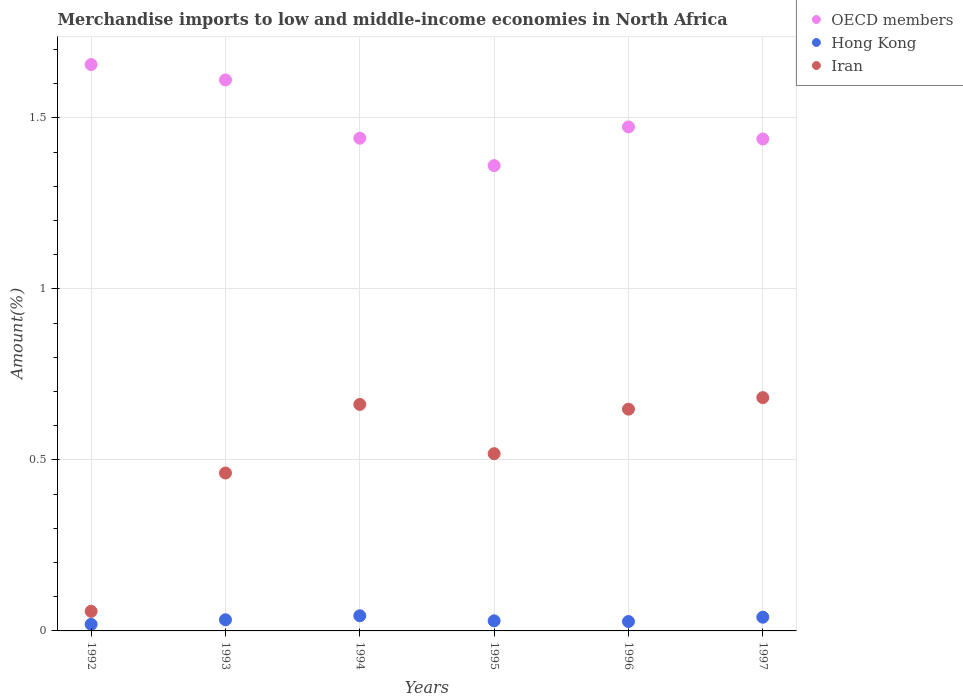What is the percentage of amount earned from merchandise imports in OECD members in 1996?
Provide a succinct answer. 1.47. Across all years, what is the maximum percentage of amount earned from merchandise imports in Hong Kong?
Keep it short and to the point. 0.04. Across all years, what is the minimum percentage of amount earned from merchandise imports in Iran?
Your response must be concise. 0.06. What is the total percentage of amount earned from merchandise imports in OECD members in the graph?
Make the answer very short. 8.98. What is the difference between the percentage of amount earned from merchandise imports in Hong Kong in 1993 and that in 1994?
Provide a short and direct response. -0.01. What is the difference between the percentage of amount earned from merchandise imports in OECD members in 1995 and the percentage of amount earned from merchandise imports in Hong Kong in 1996?
Your answer should be compact. 1.33. What is the average percentage of amount earned from merchandise imports in Iran per year?
Make the answer very short. 0.5. In the year 1993, what is the difference between the percentage of amount earned from merchandise imports in OECD members and percentage of amount earned from merchandise imports in Iran?
Ensure brevity in your answer.  1.15. What is the ratio of the percentage of amount earned from merchandise imports in Iran in 1994 to that in 1997?
Keep it short and to the point. 0.97. Is the difference between the percentage of amount earned from merchandise imports in OECD members in 1992 and 1995 greater than the difference between the percentage of amount earned from merchandise imports in Iran in 1992 and 1995?
Offer a terse response. Yes. What is the difference between the highest and the second highest percentage of amount earned from merchandise imports in Iran?
Offer a very short reply. 0.02. What is the difference between the highest and the lowest percentage of amount earned from merchandise imports in OECD members?
Provide a short and direct response. 0.3. Is the sum of the percentage of amount earned from merchandise imports in OECD members in 1993 and 1997 greater than the maximum percentage of amount earned from merchandise imports in Iran across all years?
Keep it short and to the point. Yes. Does the percentage of amount earned from merchandise imports in Iran monotonically increase over the years?
Make the answer very short. No. Is the percentage of amount earned from merchandise imports in Hong Kong strictly less than the percentage of amount earned from merchandise imports in Iran over the years?
Make the answer very short. Yes. How many years are there in the graph?
Keep it short and to the point. 6. What is the difference between two consecutive major ticks on the Y-axis?
Your answer should be very brief. 0.5. Where does the legend appear in the graph?
Give a very brief answer. Top right. How many legend labels are there?
Your answer should be very brief. 3. How are the legend labels stacked?
Provide a short and direct response. Vertical. What is the title of the graph?
Your answer should be very brief. Merchandise imports to low and middle-income economies in North Africa. Does "Gabon" appear as one of the legend labels in the graph?
Offer a very short reply. No. What is the label or title of the X-axis?
Offer a very short reply. Years. What is the label or title of the Y-axis?
Your response must be concise. Amount(%). What is the Amount(%) in OECD members in 1992?
Make the answer very short. 1.66. What is the Amount(%) in Hong Kong in 1992?
Give a very brief answer. 0.02. What is the Amount(%) of Iran in 1992?
Your answer should be compact. 0.06. What is the Amount(%) of OECD members in 1993?
Provide a short and direct response. 1.61. What is the Amount(%) of Hong Kong in 1993?
Your response must be concise. 0.03. What is the Amount(%) in Iran in 1993?
Make the answer very short. 0.46. What is the Amount(%) in OECD members in 1994?
Your answer should be compact. 1.44. What is the Amount(%) in Hong Kong in 1994?
Provide a succinct answer. 0.04. What is the Amount(%) in Iran in 1994?
Make the answer very short. 0.66. What is the Amount(%) in OECD members in 1995?
Your answer should be compact. 1.36. What is the Amount(%) in Hong Kong in 1995?
Keep it short and to the point. 0.03. What is the Amount(%) in Iran in 1995?
Provide a succinct answer. 0.52. What is the Amount(%) of OECD members in 1996?
Provide a succinct answer. 1.47. What is the Amount(%) in Hong Kong in 1996?
Your answer should be compact. 0.03. What is the Amount(%) of Iran in 1996?
Offer a very short reply. 0.65. What is the Amount(%) of OECD members in 1997?
Provide a succinct answer. 1.44. What is the Amount(%) in Hong Kong in 1997?
Give a very brief answer. 0.04. What is the Amount(%) of Iran in 1997?
Your response must be concise. 0.68. Across all years, what is the maximum Amount(%) of OECD members?
Your response must be concise. 1.66. Across all years, what is the maximum Amount(%) in Hong Kong?
Provide a succinct answer. 0.04. Across all years, what is the maximum Amount(%) of Iran?
Offer a very short reply. 0.68. Across all years, what is the minimum Amount(%) of OECD members?
Make the answer very short. 1.36. Across all years, what is the minimum Amount(%) of Hong Kong?
Your response must be concise. 0.02. Across all years, what is the minimum Amount(%) in Iran?
Offer a terse response. 0.06. What is the total Amount(%) in OECD members in the graph?
Your response must be concise. 8.98. What is the total Amount(%) of Hong Kong in the graph?
Provide a short and direct response. 0.19. What is the total Amount(%) of Iran in the graph?
Provide a short and direct response. 3.03. What is the difference between the Amount(%) in OECD members in 1992 and that in 1993?
Your answer should be compact. 0.04. What is the difference between the Amount(%) of Hong Kong in 1992 and that in 1993?
Your response must be concise. -0.01. What is the difference between the Amount(%) of Iran in 1992 and that in 1993?
Provide a short and direct response. -0.4. What is the difference between the Amount(%) of OECD members in 1992 and that in 1994?
Offer a very short reply. 0.22. What is the difference between the Amount(%) in Hong Kong in 1992 and that in 1994?
Offer a terse response. -0.03. What is the difference between the Amount(%) of Iran in 1992 and that in 1994?
Your response must be concise. -0.6. What is the difference between the Amount(%) of OECD members in 1992 and that in 1995?
Ensure brevity in your answer.  0.3. What is the difference between the Amount(%) of Hong Kong in 1992 and that in 1995?
Your answer should be very brief. -0.01. What is the difference between the Amount(%) in Iran in 1992 and that in 1995?
Your answer should be very brief. -0.46. What is the difference between the Amount(%) of OECD members in 1992 and that in 1996?
Provide a succinct answer. 0.18. What is the difference between the Amount(%) in Hong Kong in 1992 and that in 1996?
Provide a short and direct response. -0.01. What is the difference between the Amount(%) of Iran in 1992 and that in 1996?
Give a very brief answer. -0.59. What is the difference between the Amount(%) in OECD members in 1992 and that in 1997?
Your answer should be very brief. 0.22. What is the difference between the Amount(%) of Hong Kong in 1992 and that in 1997?
Your answer should be very brief. -0.02. What is the difference between the Amount(%) of Iran in 1992 and that in 1997?
Your answer should be very brief. -0.62. What is the difference between the Amount(%) in OECD members in 1993 and that in 1994?
Give a very brief answer. 0.17. What is the difference between the Amount(%) in Hong Kong in 1993 and that in 1994?
Make the answer very short. -0.01. What is the difference between the Amount(%) in Iran in 1993 and that in 1994?
Provide a short and direct response. -0.2. What is the difference between the Amount(%) of OECD members in 1993 and that in 1995?
Provide a succinct answer. 0.25. What is the difference between the Amount(%) in Hong Kong in 1993 and that in 1995?
Your response must be concise. 0. What is the difference between the Amount(%) of Iran in 1993 and that in 1995?
Give a very brief answer. -0.06. What is the difference between the Amount(%) in OECD members in 1993 and that in 1996?
Keep it short and to the point. 0.14. What is the difference between the Amount(%) of Hong Kong in 1993 and that in 1996?
Make the answer very short. 0.01. What is the difference between the Amount(%) in Iran in 1993 and that in 1996?
Provide a succinct answer. -0.19. What is the difference between the Amount(%) in OECD members in 1993 and that in 1997?
Your response must be concise. 0.17. What is the difference between the Amount(%) in Hong Kong in 1993 and that in 1997?
Give a very brief answer. -0.01. What is the difference between the Amount(%) in Iran in 1993 and that in 1997?
Make the answer very short. -0.22. What is the difference between the Amount(%) of OECD members in 1994 and that in 1995?
Your answer should be very brief. 0.08. What is the difference between the Amount(%) of Hong Kong in 1994 and that in 1995?
Provide a short and direct response. 0.01. What is the difference between the Amount(%) of Iran in 1994 and that in 1995?
Ensure brevity in your answer.  0.14. What is the difference between the Amount(%) of OECD members in 1994 and that in 1996?
Provide a short and direct response. -0.03. What is the difference between the Amount(%) in Hong Kong in 1994 and that in 1996?
Provide a succinct answer. 0.02. What is the difference between the Amount(%) in Iran in 1994 and that in 1996?
Your answer should be very brief. 0.01. What is the difference between the Amount(%) of OECD members in 1994 and that in 1997?
Your answer should be very brief. 0. What is the difference between the Amount(%) of Hong Kong in 1994 and that in 1997?
Provide a succinct answer. 0. What is the difference between the Amount(%) of Iran in 1994 and that in 1997?
Give a very brief answer. -0.02. What is the difference between the Amount(%) in OECD members in 1995 and that in 1996?
Provide a short and direct response. -0.11. What is the difference between the Amount(%) of Hong Kong in 1995 and that in 1996?
Keep it short and to the point. 0. What is the difference between the Amount(%) of Iran in 1995 and that in 1996?
Your answer should be compact. -0.13. What is the difference between the Amount(%) in OECD members in 1995 and that in 1997?
Ensure brevity in your answer.  -0.08. What is the difference between the Amount(%) of Hong Kong in 1995 and that in 1997?
Your response must be concise. -0.01. What is the difference between the Amount(%) of Iran in 1995 and that in 1997?
Give a very brief answer. -0.16. What is the difference between the Amount(%) in OECD members in 1996 and that in 1997?
Offer a terse response. 0.04. What is the difference between the Amount(%) of Hong Kong in 1996 and that in 1997?
Offer a terse response. -0.01. What is the difference between the Amount(%) of Iran in 1996 and that in 1997?
Your response must be concise. -0.03. What is the difference between the Amount(%) in OECD members in 1992 and the Amount(%) in Hong Kong in 1993?
Keep it short and to the point. 1.62. What is the difference between the Amount(%) of OECD members in 1992 and the Amount(%) of Iran in 1993?
Offer a terse response. 1.19. What is the difference between the Amount(%) of Hong Kong in 1992 and the Amount(%) of Iran in 1993?
Make the answer very short. -0.44. What is the difference between the Amount(%) in OECD members in 1992 and the Amount(%) in Hong Kong in 1994?
Give a very brief answer. 1.61. What is the difference between the Amount(%) of OECD members in 1992 and the Amount(%) of Iran in 1994?
Provide a short and direct response. 0.99. What is the difference between the Amount(%) in Hong Kong in 1992 and the Amount(%) in Iran in 1994?
Give a very brief answer. -0.64. What is the difference between the Amount(%) of OECD members in 1992 and the Amount(%) of Hong Kong in 1995?
Offer a very short reply. 1.63. What is the difference between the Amount(%) in OECD members in 1992 and the Amount(%) in Iran in 1995?
Keep it short and to the point. 1.14. What is the difference between the Amount(%) of Hong Kong in 1992 and the Amount(%) of Iran in 1995?
Offer a very short reply. -0.5. What is the difference between the Amount(%) of OECD members in 1992 and the Amount(%) of Hong Kong in 1996?
Keep it short and to the point. 1.63. What is the difference between the Amount(%) of OECD members in 1992 and the Amount(%) of Iran in 1996?
Provide a succinct answer. 1.01. What is the difference between the Amount(%) in Hong Kong in 1992 and the Amount(%) in Iran in 1996?
Your answer should be compact. -0.63. What is the difference between the Amount(%) in OECD members in 1992 and the Amount(%) in Hong Kong in 1997?
Offer a terse response. 1.62. What is the difference between the Amount(%) in OECD members in 1992 and the Amount(%) in Iran in 1997?
Your response must be concise. 0.97. What is the difference between the Amount(%) in Hong Kong in 1992 and the Amount(%) in Iran in 1997?
Ensure brevity in your answer.  -0.66. What is the difference between the Amount(%) of OECD members in 1993 and the Amount(%) of Hong Kong in 1994?
Ensure brevity in your answer.  1.57. What is the difference between the Amount(%) of OECD members in 1993 and the Amount(%) of Iran in 1994?
Offer a terse response. 0.95. What is the difference between the Amount(%) of Hong Kong in 1993 and the Amount(%) of Iran in 1994?
Your response must be concise. -0.63. What is the difference between the Amount(%) of OECD members in 1993 and the Amount(%) of Hong Kong in 1995?
Make the answer very short. 1.58. What is the difference between the Amount(%) of OECD members in 1993 and the Amount(%) of Iran in 1995?
Give a very brief answer. 1.09. What is the difference between the Amount(%) in Hong Kong in 1993 and the Amount(%) in Iran in 1995?
Ensure brevity in your answer.  -0.49. What is the difference between the Amount(%) of OECD members in 1993 and the Amount(%) of Hong Kong in 1996?
Provide a succinct answer. 1.58. What is the difference between the Amount(%) of OECD members in 1993 and the Amount(%) of Iran in 1996?
Make the answer very short. 0.96. What is the difference between the Amount(%) in Hong Kong in 1993 and the Amount(%) in Iran in 1996?
Keep it short and to the point. -0.62. What is the difference between the Amount(%) in OECD members in 1993 and the Amount(%) in Hong Kong in 1997?
Offer a very short reply. 1.57. What is the difference between the Amount(%) in OECD members in 1993 and the Amount(%) in Iran in 1997?
Make the answer very short. 0.93. What is the difference between the Amount(%) of Hong Kong in 1993 and the Amount(%) of Iran in 1997?
Provide a succinct answer. -0.65. What is the difference between the Amount(%) of OECD members in 1994 and the Amount(%) of Hong Kong in 1995?
Make the answer very short. 1.41. What is the difference between the Amount(%) of OECD members in 1994 and the Amount(%) of Iran in 1995?
Ensure brevity in your answer.  0.92. What is the difference between the Amount(%) in Hong Kong in 1994 and the Amount(%) in Iran in 1995?
Make the answer very short. -0.47. What is the difference between the Amount(%) in OECD members in 1994 and the Amount(%) in Hong Kong in 1996?
Make the answer very short. 1.41. What is the difference between the Amount(%) of OECD members in 1994 and the Amount(%) of Iran in 1996?
Ensure brevity in your answer.  0.79. What is the difference between the Amount(%) of Hong Kong in 1994 and the Amount(%) of Iran in 1996?
Your answer should be compact. -0.6. What is the difference between the Amount(%) of OECD members in 1994 and the Amount(%) of Hong Kong in 1997?
Your answer should be very brief. 1.4. What is the difference between the Amount(%) of OECD members in 1994 and the Amount(%) of Iran in 1997?
Offer a very short reply. 0.76. What is the difference between the Amount(%) in Hong Kong in 1994 and the Amount(%) in Iran in 1997?
Ensure brevity in your answer.  -0.64. What is the difference between the Amount(%) in OECD members in 1995 and the Amount(%) in Hong Kong in 1996?
Your response must be concise. 1.33. What is the difference between the Amount(%) of OECD members in 1995 and the Amount(%) of Iran in 1996?
Offer a very short reply. 0.71. What is the difference between the Amount(%) of Hong Kong in 1995 and the Amount(%) of Iran in 1996?
Keep it short and to the point. -0.62. What is the difference between the Amount(%) in OECD members in 1995 and the Amount(%) in Hong Kong in 1997?
Your answer should be very brief. 1.32. What is the difference between the Amount(%) of OECD members in 1995 and the Amount(%) of Iran in 1997?
Offer a terse response. 0.68. What is the difference between the Amount(%) in Hong Kong in 1995 and the Amount(%) in Iran in 1997?
Provide a short and direct response. -0.65. What is the difference between the Amount(%) of OECD members in 1996 and the Amount(%) of Hong Kong in 1997?
Give a very brief answer. 1.43. What is the difference between the Amount(%) in OECD members in 1996 and the Amount(%) in Iran in 1997?
Provide a succinct answer. 0.79. What is the difference between the Amount(%) of Hong Kong in 1996 and the Amount(%) of Iran in 1997?
Keep it short and to the point. -0.65. What is the average Amount(%) of OECD members per year?
Offer a very short reply. 1.5. What is the average Amount(%) of Hong Kong per year?
Your response must be concise. 0.03. What is the average Amount(%) of Iran per year?
Your answer should be very brief. 0.5. In the year 1992, what is the difference between the Amount(%) of OECD members and Amount(%) of Hong Kong?
Ensure brevity in your answer.  1.64. In the year 1992, what is the difference between the Amount(%) in OECD members and Amount(%) in Iran?
Provide a short and direct response. 1.6. In the year 1992, what is the difference between the Amount(%) in Hong Kong and Amount(%) in Iran?
Provide a short and direct response. -0.04. In the year 1993, what is the difference between the Amount(%) in OECD members and Amount(%) in Hong Kong?
Keep it short and to the point. 1.58. In the year 1993, what is the difference between the Amount(%) of OECD members and Amount(%) of Iran?
Provide a succinct answer. 1.15. In the year 1993, what is the difference between the Amount(%) in Hong Kong and Amount(%) in Iran?
Provide a succinct answer. -0.43. In the year 1994, what is the difference between the Amount(%) of OECD members and Amount(%) of Hong Kong?
Provide a short and direct response. 1.4. In the year 1994, what is the difference between the Amount(%) of OECD members and Amount(%) of Iran?
Provide a succinct answer. 0.78. In the year 1994, what is the difference between the Amount(%) in Hong Kong and Amount(%) in Iran?
Make the answer very short. -0.62. In the year 1995, what is the difference between the Amount(%) in OECD members and Amount(%) in Hong Kong?
Your response must be concise. 1.33. In the year 1995, what is the difference between the Amount(%) in OECD members and Amount(%) in Iran?
Your response must be concise. 0.84. In the year 1995, what is the difference between the Amount(%) in Hong Kong and Amount(%) in Iran?
Offer a terse response. -0.49. In the year 1996, what is the difference between the Amount(%) of OECD members and Amount(%) of Hong Kong?
Provide a succinct answer. 1.45. In the year 1996, what is the difference between the Amount(%) in OECD members and Amount(%) in Iran?
Your answer should be compact. 0.82. In the year 1996, what is the difference between the Amount(%) of Hong Kong and Amount(%) of Iran?
Give a very brief answer. -0.62. In the year 1997, what is the difference between the Amount(%) in OECD members and Amount(%) in Hong Kong?
Ensure brevity in your answer.  1.4. In the year 1997, what is the difference between the Amount(%) of OECD members and Amount(%) of Iran?
Your answer should be very brief. 0.76. In the year 1997, what is the difference between the Amount(%) in Hong Kong and Amount(%) in Iran?
Offer a very short reply. -0.64. What is the ratio of the Amount(%) of OECD members in 1992 to that in 1993?
Give a very brief answer. 1.03. What is the ratio of the Amount(%) of Hong Kong in 1992 to that in 1993?
Offer a very short reply. 0.59. What is the ratio of the Amount(%) of Iran in 1992 to that in 1993?
Provide a short and direct response. 0.12. What is the ratio of the Amount(%) of OECD members in 1992 to that in 1994?
Give a very brief answer. 1.15. What is the ratio of the Amount(%) of Hong Kong in 1992 to that in 1994?
Provide a short and direct response. 0.43. What is the ratio of the Amount(%) of Iran in 1992 to that in 1994?
Your answer should be very brief. 0.09. What is the ratio of the Amount(%) in OECD members in 1992 to that in 1995?
Ensure brevity in your answer.  1.22. What is the ratio of the Amount(%) in Hong Kong in 1992 to that in 1995?
Your answer should be compact. 0.65. What is the ratio of the Amount(%) in Iran in 1992 to that in 1995?
Provide a short and direct response. 0.11. What is the ratio of the Amount(%) of OECD members in 1992 to that in 1996?
Your answer should be very brief. 1.12. What is the ratio of the Amount(%) in Hong Kong in 1992 to that in 1996?
Offer a terse response. 0.7. What is the ratio of the Amount(%) of Iran in 1992 to that in 1996?
Ensure brevity in your answer.  0.09. What is the ratio of the Amount(%) of OECD members in 1992 to that in 1997?
Offer a very short reply. 1.15. What is the ratio of the Amount(%) of Hong Kong in 1992 to that in 1997?
Offer a very short reply. 0.48. What is the ratio of the Amount(%) in Iran in 1992 to that in 1997?
Make the answer very short. 0.08. What is the ratio of the Amount(%) of OECD members in 1993 to that in 1994?
Provide a succinct answer. 1.12. What is the ratio of the Amount(%) of Hong Kong in 1993 to that in 1994?
Your response must be concise. 0.74. What is the ratio of the Amount(%) of Iran in 1993 to that in 1994?
Give a very brief answer. 0.7. What is the ratio of the Amount(%) of OECD members in 1993 to that in 1995?
Your response must be concise. 1.18. What is the ratio of the Amount(%) of Hong Kong in 1993 to that in 1995?
Ensure brevity in your answer.  1.1. What is the ratio of the Amount(%) of Iran in 1993 to that in 1995?
Your answer should be compact. 0.89. What is the ratio of the Amount(%) in OECD members in 1993 to that in 1996?
Ensure brevity in your answer.  1.09. What is the ratio of the Amount(%) of Hong Kong in 1993 to that in 1996?
Provide a short and direct response. 1.19. What is the ratio of the Amount(%) in Iran in 1993 to that in 1996?
Make the answer very short. 0.71. What is the ratio of the Amount(%) of OECD members in 1993 to that in 1997?
Keep it short and to the point. 1.12. What is the ratio of the Amount(%) in Hong Kong in 1993 to that in 1997?
Your response must be concise. 0.81. What is the ratio of the Amount(%) of Iran in 1993 to that in 1997?
Your answer should be very brief. 0.68. What is the ratio of the Amount(%) in OECD members in 1994 to that in 1995?
Ensure brevity in your answer.  1.06. What is the ratio of the Amount(%) of Hong Kong in 1994 to that in 1995?
Provide a short and direct response. 1.5. What is the ratio of the Amount(%) in Iran in 1994 to that in 1995?
Your answer should be very brief. 1.28. What is the ratio of the Amount(%) in OECD members in 1994 to that in 1996?
Ensure brevity in your answer.  0.98. What is the ratio of the Amount(%) in Hong Kong in 1994 to that in 1996?
Provide a short and direct response. 1.61. What is the ratio of the Amount(%) in Iran in 1994 to that in 1996?
Your answer should be compact. 1.02. What is the ratio of the Amount(%) of Hong Kong in 1994 to that in 1997?
Provide a short and direct response. 1.1. What is the ratio of the Amount(%) of Iran in 1994 to that in 1997?
Your response must be concise. 0.97. What is the ratio of the Amount(%) in OECD members in 1995 to that in 1996?
Your response must be concise. 0.92. What is the ratio of the Amount(%) in Hong Kong in 1995 to that in 1996?
Make the answer very short. 1.08. What is the ratio of the Amount(%) of Iran in 1995 to that in 1996?
Offer a very short reply. 0.8. What is the ratio of the Amount(%) of OECD members in 1995 to that in 1997?
Your answer should be very brief. 0.95. What is the ratio of the Amount(%) of Hong Kong in 1995 to that in 1997?
Provide a short and direct response. 0.74. What is the ratio of the Amount(%) of Iran in 1995 to that in 1997?
Provide a short and direct response. 0.76. What is the ratio of the Amount(%) in OECD members in 1996 to that in 1997?
Your response must be concise. 1.02. What is the ratio of the Amount(%) in Hong Kong in 1996 to that in 1997?
Offer a very short reply. 0.68. What is the ratio of the Amount(%) in Iran in 1996 to that in 1997?
Provide a short and direct response. 0.95. What is the difference between the highest and the second highest Amount(%) in OECD members?
Your answer should be compact. 0.04. What is the difference between the highest and the second highest Amount(%) of Hong Kong?
Your response must be concise. 0. What is the difference between the highest and the second highest Amount(%) of Iran?
Make the answer very short. 0.02. What is the difference between the highest and the lowest Amount(%) of OECD members?
Keep it short and to the point. 0.3. What is the difference between the highest and the lowest Amount(%) in Hong Kong?
Provide a short and direct response. 0.03. What is the difference between the highest and the lowest Amount(%) in Iran?
Provide a short and direct response. 0.62. 